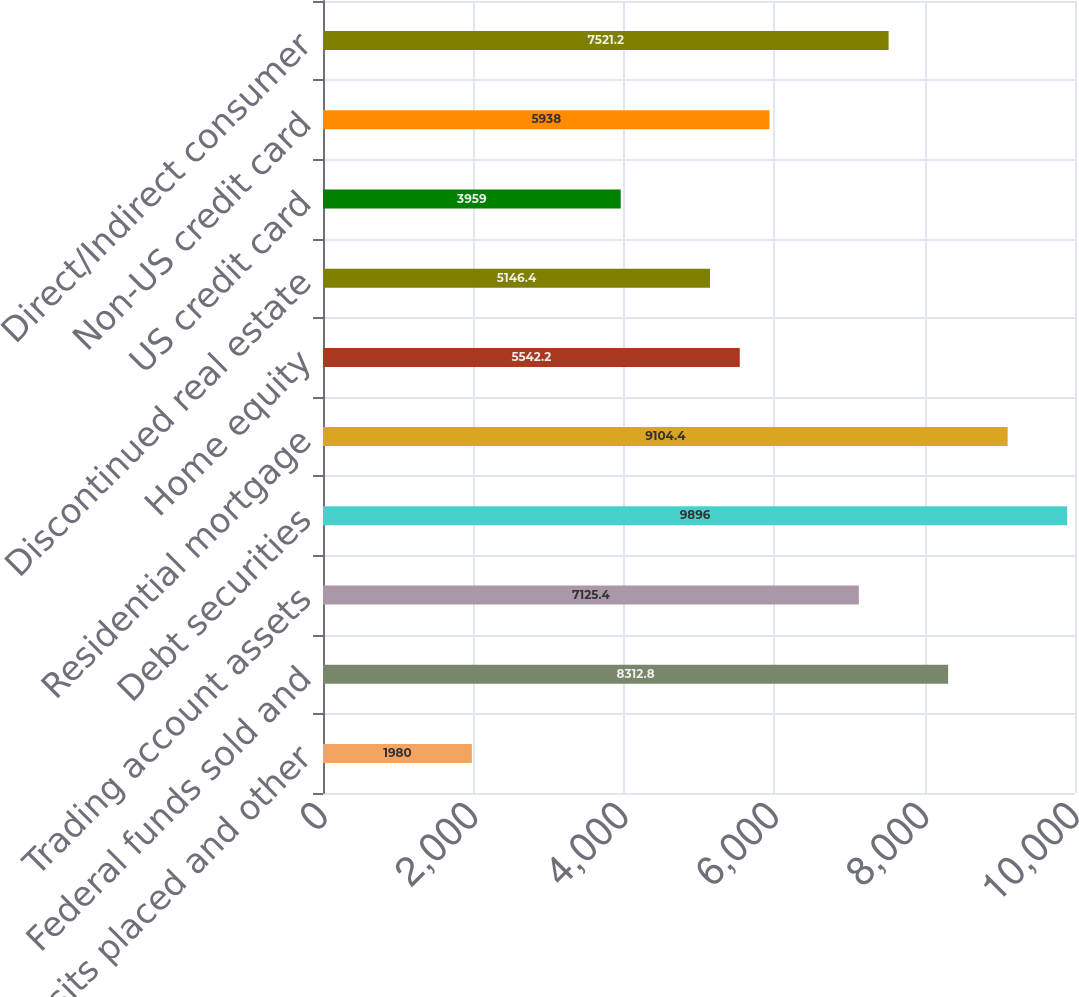<chart> <loc_0><loc_0><loc_500><loc_500><bar_chart><fcel>Time deposits placed and other<fcel>Federal funds sold and<fcel>Trading account assets<fcel>Debt securities<fcel>Residential mortgage<fcel>Home equity<fcel>Discontinued real estate<fcel>US credit card<fcel>Non-US credit card<fcel>Direct/Indirect consumer<nl><fcel>1980<fcel>8312.8<fcel>7125.4<fcel>9896<fcel>9104.4<fcel>5542.2<fcel>5146.4<fcel>3959<fcel>5938<fcel>7521.2<nl></chart> 